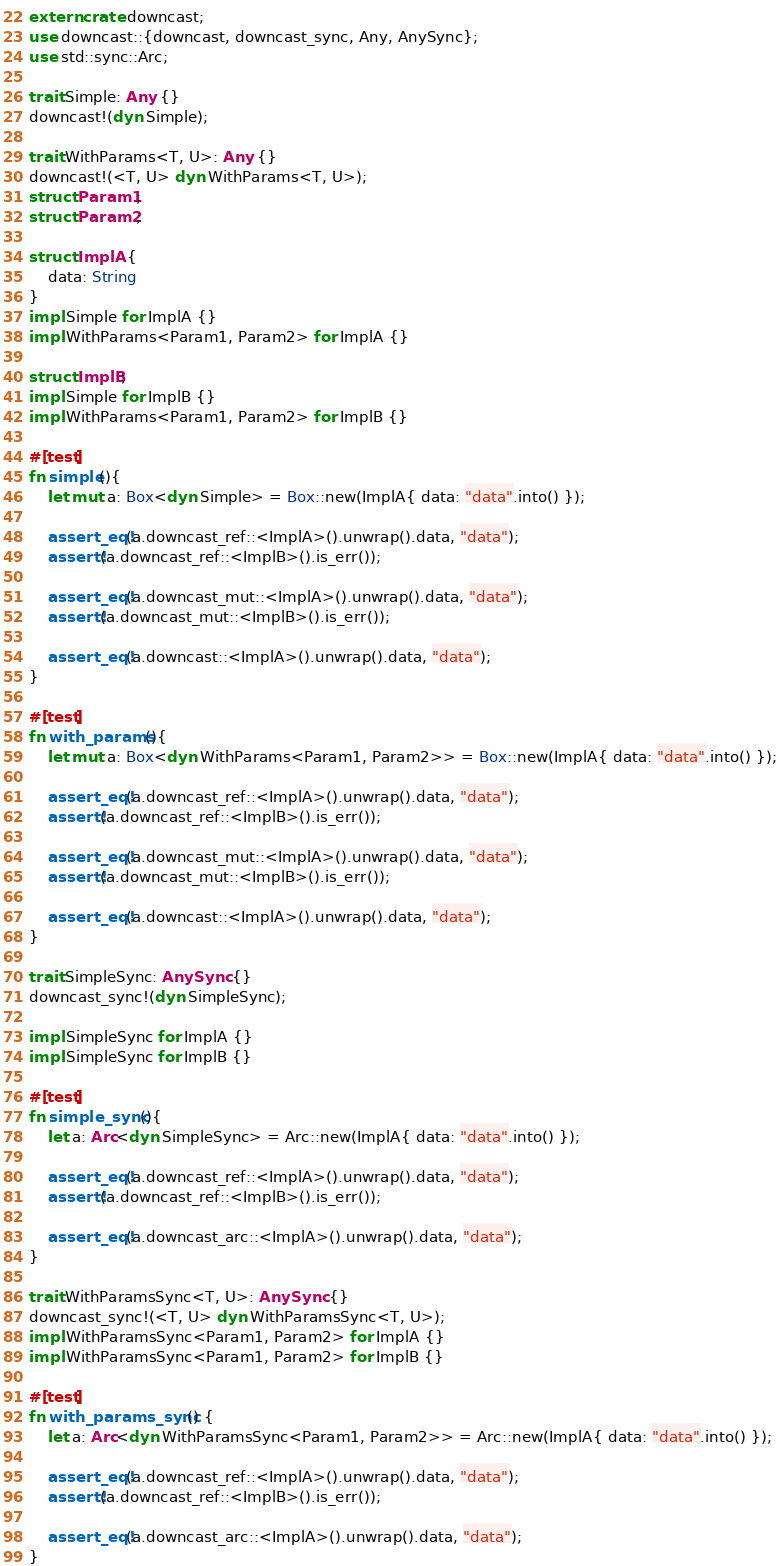<code> <loc_0><loc_0><loc_500><loc_500><_Rust_>extern crate downcast;
use downcast::{downcast, downcast_sync, Any, AnySync};
use std::sync::Arc;

trait Simple: Any {}
downcast!(dyn Simple);

trait WithParams<T, U>: Any {}
downcast!(<T, U> dyn WithParams<T, U>);
struct Param1;
struct Param2;

struct ImplA {
    data: String
}
impl Simple for ImplA {}
impl WithParams<Param1, Param2> for ImplA {}

struct ImplB;
impl Simple for ImplB {}
impl WithParams<Param1, Param2> for ImplB {}

#[test]
fn simple(){
    let mut a: Box<dyn Simple> = Box::new(ImplA{ data: "data".into() });

    assert_eq!(a.downcast_ref::<ImplA>().unwrap().data, "data");
    assert!(a.downcast_ref::<ImplB>().is_err());

    assert_eq!(a.downcast_mut::<ImplA>().unwrap().data, "data");
    assert!(a.downcast_mut::<ImplB>().is_err());

    assert_eq!(a.downcast::<ImplA>().unwrap().data, "data");
}

#[test]
fn with_params(){
    let mut a: Box<dyn WithParams<Param1, Param2>> = Box::new(ImplA{ data: "data".into() });

    assert_eq!(a.downcast_ref::<ImplA>().unwrap().data, "data");
    assert!(a.downcast_ref::<ImplB>().is_err());

    assert_eq!(a.downcast_mut::<ImplA>().unwrap().data, "data");
    assert!(a.downcast_mut::<ImplB>().is_err());

    assert_eq!(a.downcast::<ImplA>().unwrap().data, "data");
}

trait SimpleSync: AnySync {}
downcast_sync!(dyn SimpleSync);

impl SimpleSync for ImplA {}
impl SimpleSync for ImplB {}

#[test]
fn simple_sync(){
    let a: Arc<dyn SimpleSync> = Arc::new(ImplA{ data: "data".into() });

    assert_eq!(a.downcast_ref::<ImplA>().unwrap().data, "data");
    assert!(a.downcast_ref::<ImplB>().is_err());

    assert_eq!(a.downcast_arc::<ImplA>().unwrap().data, "data");
}

trait WithParamsSync<T, U>: AnySync {}
downcast_sync!(<T, U> dyn WithParamsSync<T, U>);
impl WithParamsSync<Param1, Param2> for ImplA {}
impl WithParamsSync<Param1, Param2> for ImplB {}

#[test]
fn with_params_sync() {
    let a: Arc<dyn WithParamsSync<Param1, Param2>> = Arc::new(ImplA{ data: "data".into() });

    assert_eq!(a.downcast_ref::<ImplA>().unwrap().data, "data");
    assert!(a.downcast_ref::<ImplB>().is_err());

    assert_eq!(a.downcast_arc::<ImplA>().unwrap().data, "data");
}
</code> 